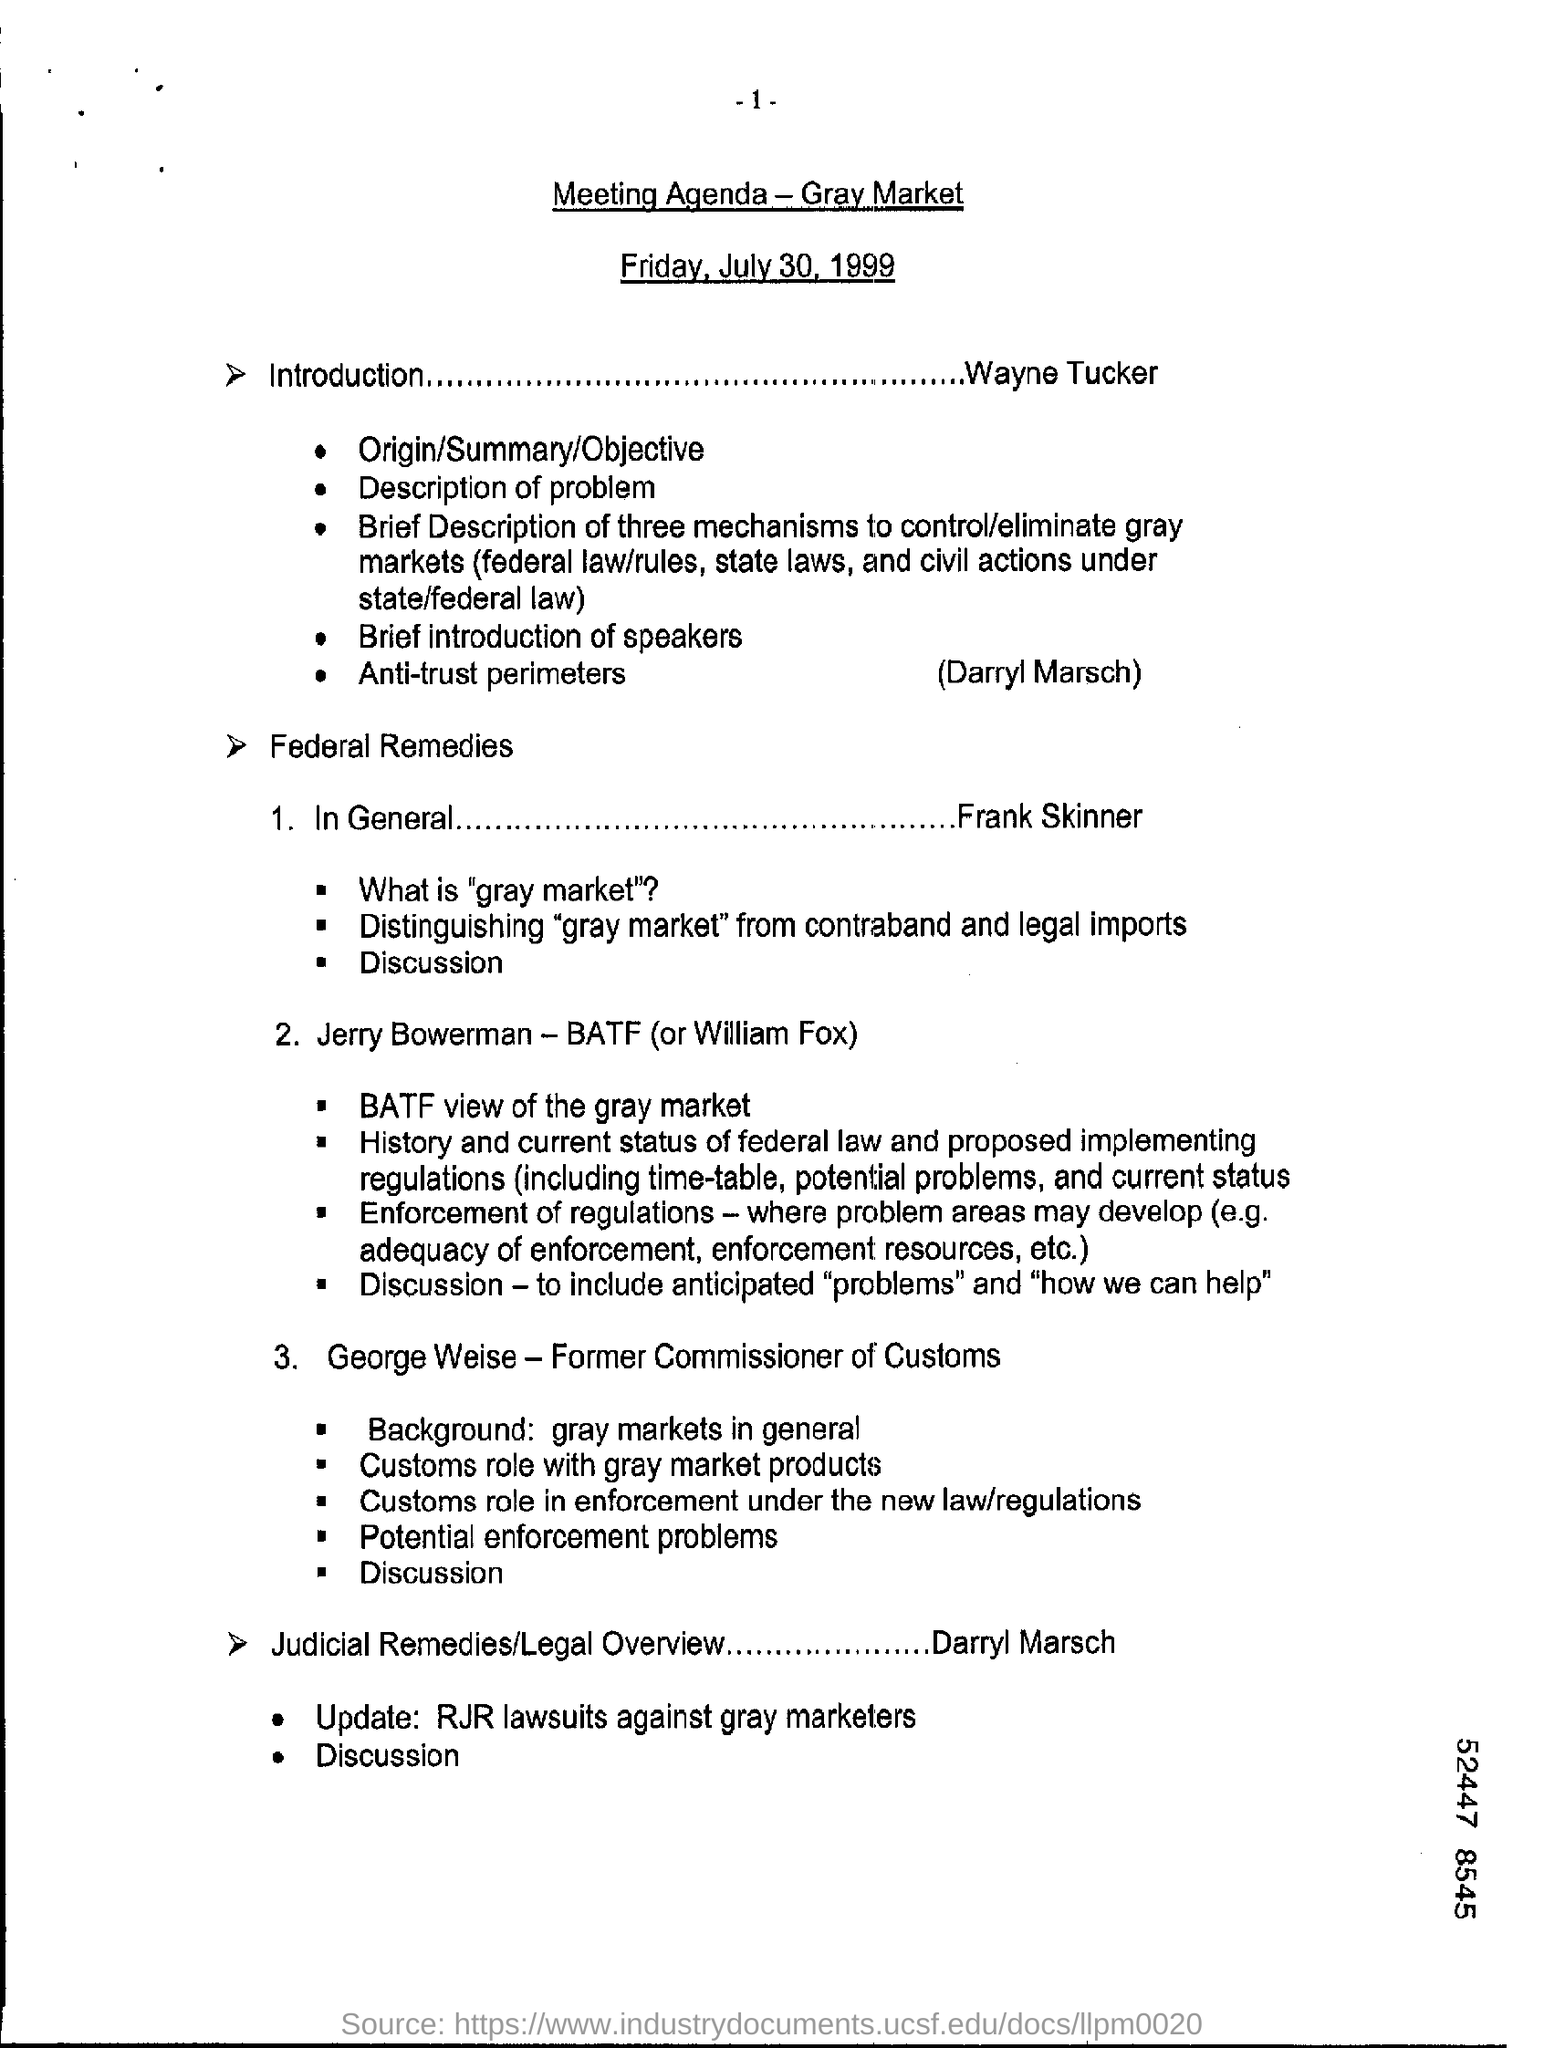Point out several critical features in this image. The title of this meeting is 'Meeting Agenda - Gray Market.' The document indicates that the date mentioned is Friday, July 30, 1999. 